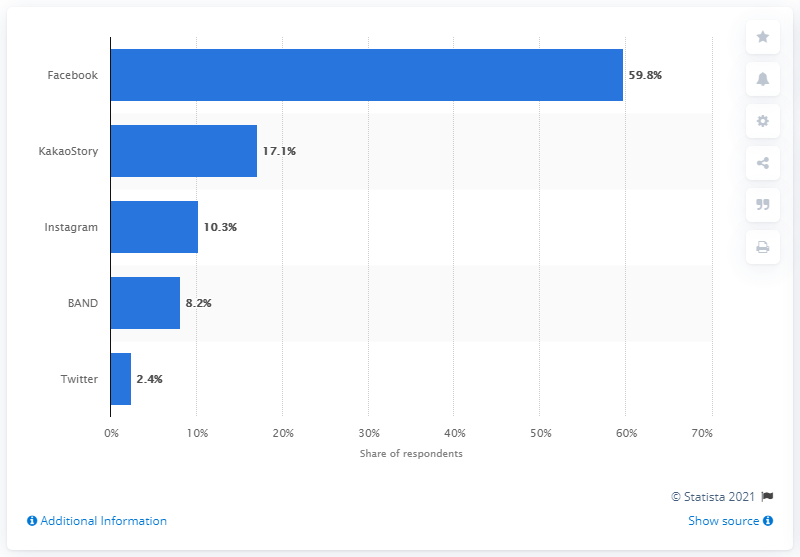List a handful of essential elements in this visual. According to data from December 2015, Facebook was the most popular social networking service in South Korea. 